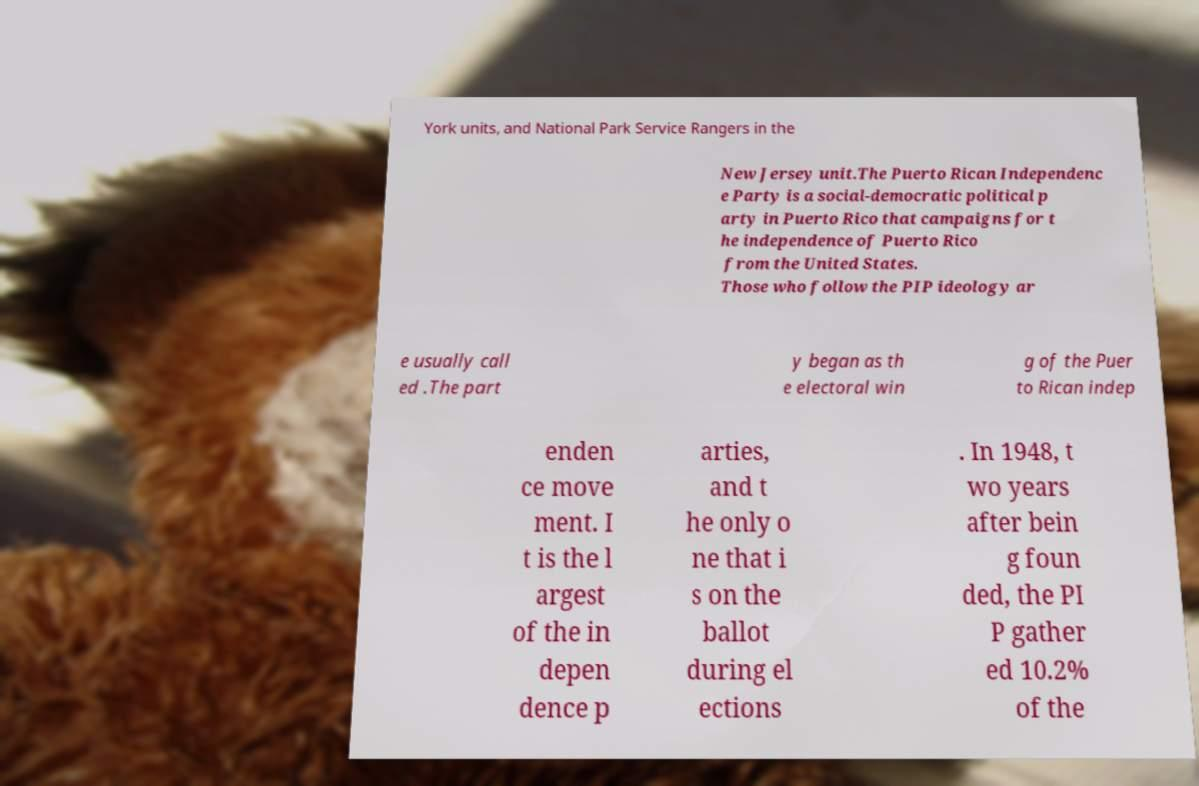There's text embedded in this image that I need extracted. Can you transcribe it verbatim? York units, and National Park Service Rangers in the New Jersey unit.The Puerto Rican Independenc e Party is a social-democratic political p arty in Puerto Rico that campaigns for t he independence of Puerto Rico from the United States. Those who follow the PIP ideology ar e usually call ed .The part y began as th e electoral win g of the Puer to Rican indep enden ce move ment. I t is the l argest of the in depen dence p arties, and t he only o ne that i s on the ballot during el ections . In 1948, t wo years after bein g foun ded, the PI P gather ed 10.2% of the 